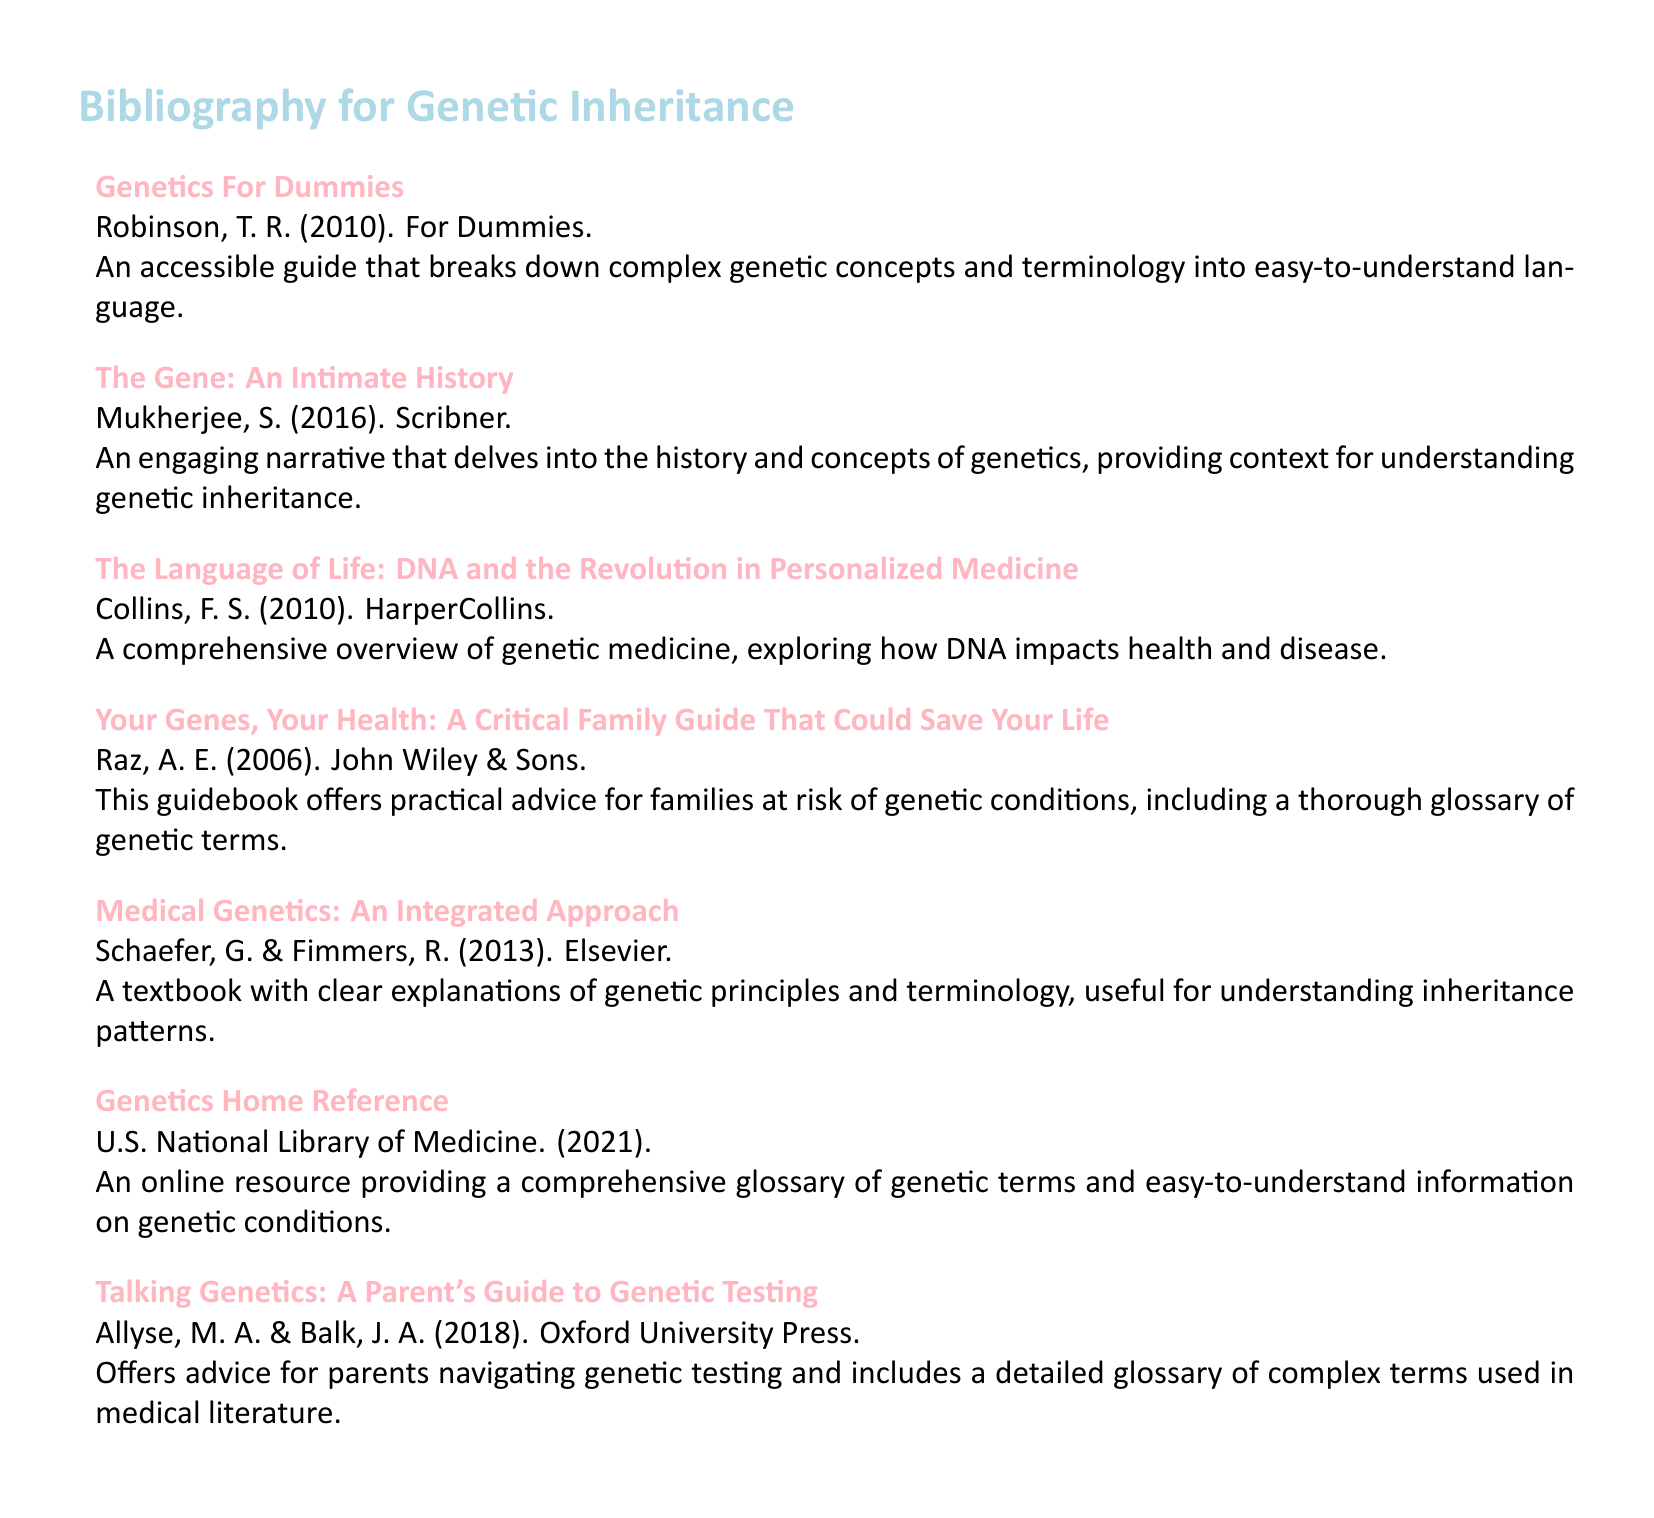what is the title of the first entry in the bibliography? The title of the first entry is listed as "Genetics For Dummies."
Answer: Genetics For Dummies who is the author of "The Gene: An Intimate History"? The author of "The Gene: An Intimate History" is Shukla Mukherjee.
Answer: Mukherjee, S what year was "Your Genes, Your Health" published? The publication year for "Your Genes, Your Health" is indicated in the document as 2006.
Answer: 2006 which entry provides advice for parents navigating genetic testing? The entry specifying advice for parents navigating genetic testing is "Talking Genetics: A Parent's Guide to Genetic Testing."
Answer: Talking Genetics: A Parent's Guide to Genetic Testing how many entries in total are there in the bibliography? The total number of entries in the bibliography is counted as seven.
Answer: 7 which source is described as an online resource for genetic terms? The bibliographic entry describing an online resource is "Genetics Home Reference."
Answer: Genetics Home Reference what is a key theme of "The Language of Life"? The key theme of "The Language of Life" involves the impact of DNA on health and disease.
Answer: DNA impacts health and disease who published "Medical Genetics: An Integrated Approach"? The publisher of "Medical Genetics: An Integrated Approach" is Elsevier.
Answer: Elsevier 